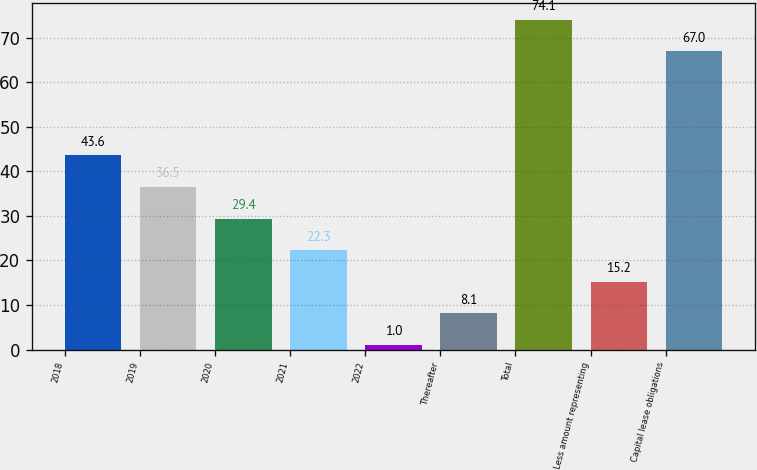Convert chart. <chart><loc_0><loc_0><loc_500><loc_500><bar_chart><fcel>2018<fcel>2019<fcel>2020<fcel>2021<fcel>2022<fcel>Thereafter<fcel>Total<fcel>Less amount representing<fcel>Capital lease obligations<nl><fcel>43.6<fcel>36.5<fcel>29.4<fcel>22.3<fcel>1<fcel>8.1<fcel>74.1<fcel>15.2<fcel>67<nl></chart> 